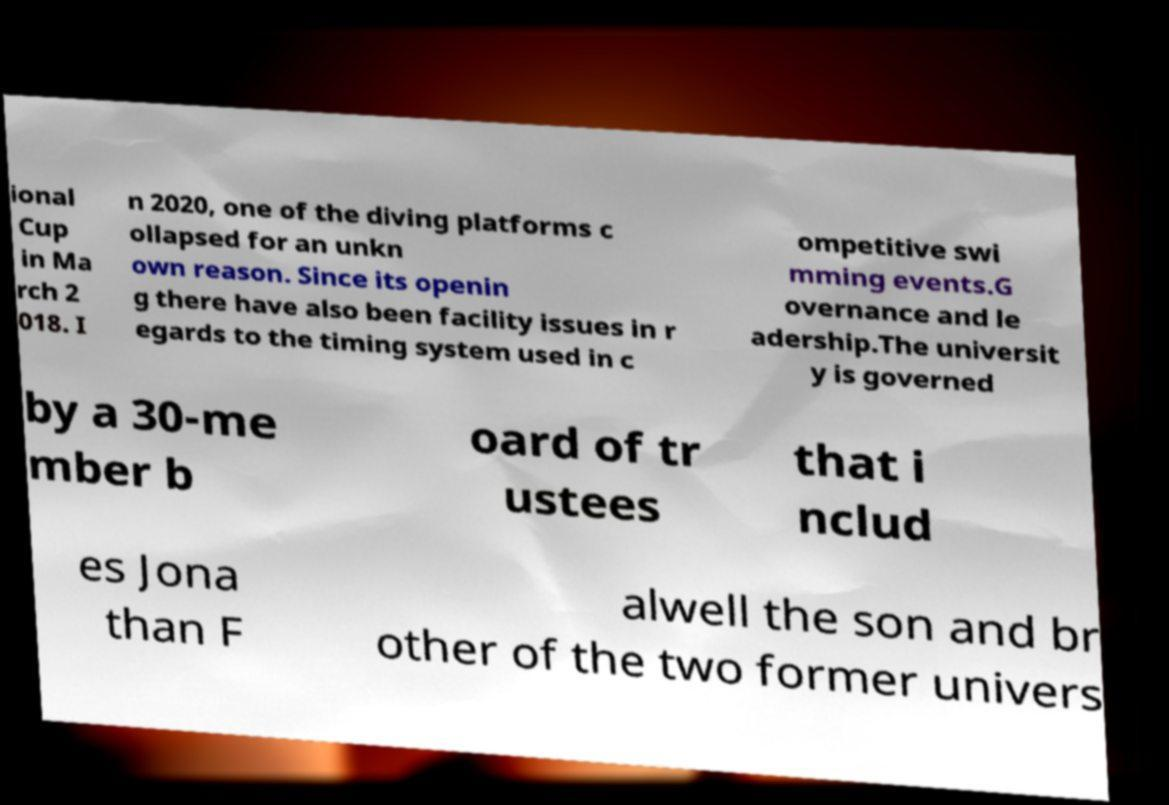For documentation purposes, I need the text within this image transcribed. Could you provide that? ional Cup in Ma rch 2 018. I n 2020, one of the diving platforms c ollapsed for an unkn own reason. Since its openin g there have also been facility issues in r egards to the timing system used in c ompetitive swi mming events.G overnance and le adership.The universit y is governed by a 30-me mber b oard of tr ustees that i nclud es Jona than F alwell the son and br other of the two former univers 